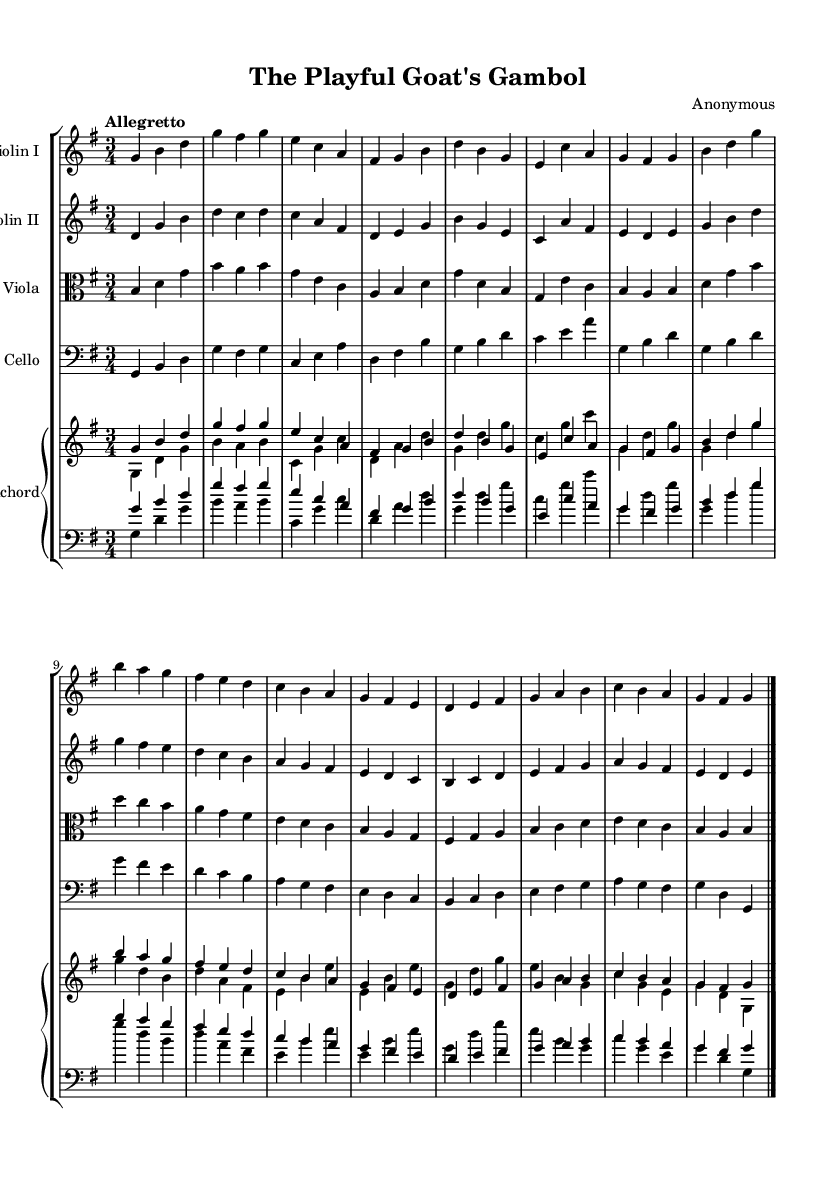What is the key signature of this music? The key signature indicates that there are no sharps or flats, which corresponds to G major. This is determined by looking at the beginning of the staff where the key signature is located.
Answer: G major What is the time signature of the piece? The time signature is indicated at the beginning as 3/4, which means there are three beats per measure and the quarter note receives one beat. This is established by examining the symbol after the key signature.
Answer: 3/4 What is the tempo marking for this music? The tempo is marked as "Allegretto," which implies a moderately fast pace. This can be found in the tempo indication at the beginning of the music, which sets the character of the piece.
Answer: Allegretto How many instruments are written in the score? The score contains four distinct instruments: Violin I, Violin II, Viola, and Cello, along with a two-staff Harpsichord. Counting the separate staves confirms this.
Answer: Five Which instrument is playing the melody predominantly? The melody is primarily played by Violin I, as it is positioned above the other instruments in the score and has the most prominent musical line throughout the piece.
Answer: Violin I What type of musical form is commonly used in Baroque suites, which appears in this music? This piece fits the typical structure of a Baroque suite, which often includes dances. In this case, the suite conveys whimsical and playful characteristics, reflecting the nature of the featured young animals.
Answer: Suite What is the rhythmic value of the first note in Violin II? The first note in Violin II is a D note, played as a quarter note. Observing the rhythmic notation at the beginning of the staff gives us the duration of the note.
Answer: D quarter note 